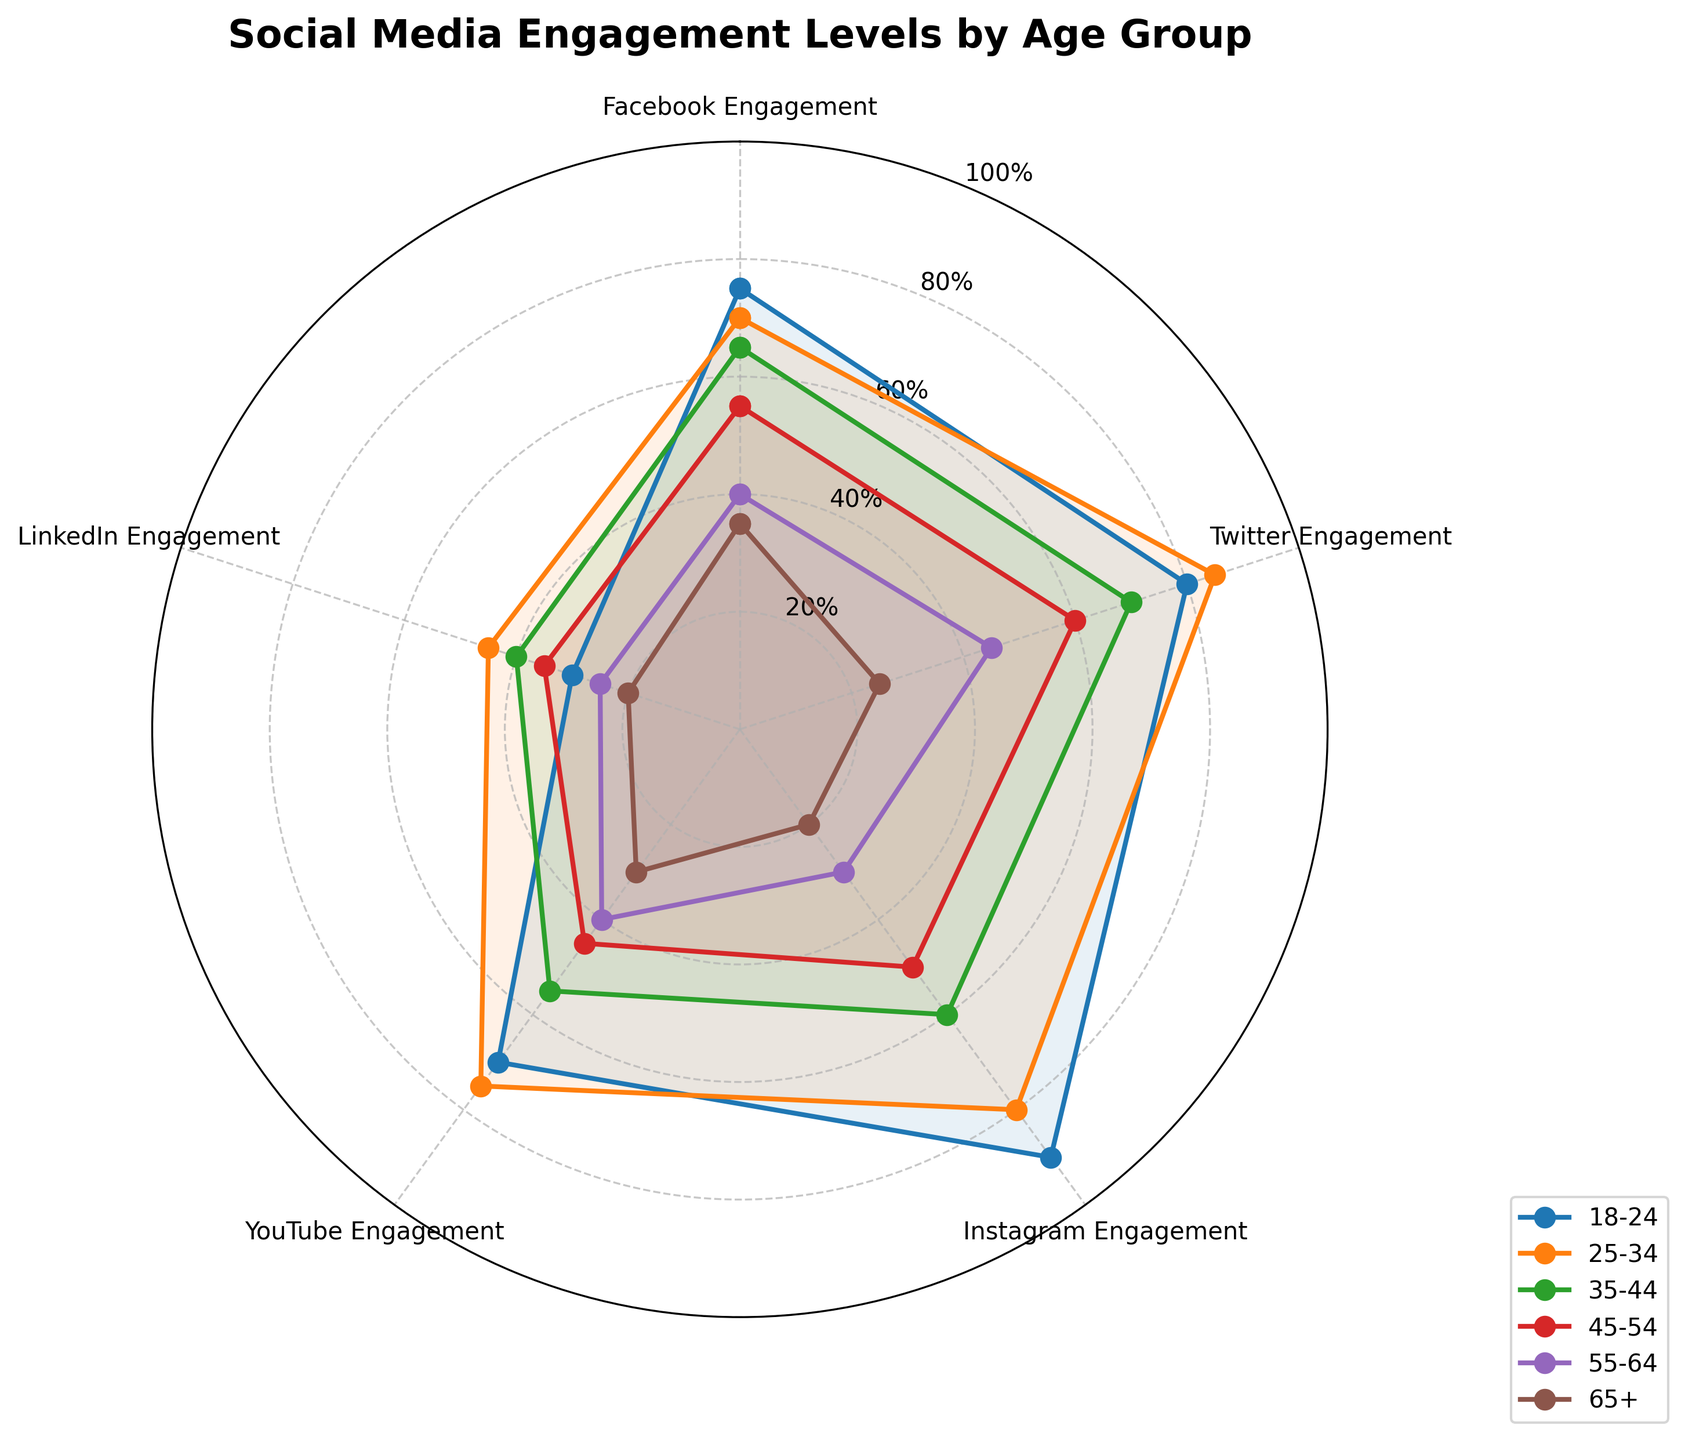What is the title of the chart? The title of the chart is written at the top of the figure, centered and in bold font. It reads "Social Media Engagement Levels by Age Group."
Answer: Social Media Engagement Levels by Age Group How many age groups are displayed in the chart? There are sections of the radial lines each representing different age groups. Count the number of unique labels that are plotted along the lines representing age groups.
Answer: Six Which age group has the highest engagement on Instagram? Look at the points corresponding to Instagram for each age group and identify the highest value. The age group with the peak value is the one with the highest engagement.
Answer: 18-24 Compare the Facebook engagement levels between age groups 18-24 and 65+. Which one is higher? Locate the points for Facebook engagement of age groups 18-24 and 65+. The line for the 18-24 age group reaches higher on the radial scale than the 65+ line.
Answer: 18-24 What is the average YouTube engagement level for the age groups 18-24 and 45-54 combined? Add the YouTube engagement values for 18-24 and 45-54 age groups (70 and 45), then divide by 2 to find the average: (70+45)/2.
Answer: 57.5 Which social media platform has the highest engagement for the age group 25-34? Identify the highest value among the points corresponding to the 25-34 age group across all social media platforms. The peak is on Twitter at 85.
Answer: Twitter What is the difference in LinkedIn engagement between the age groups 35-44 and 55-64? Subtract the LinkedIn engagement value for the 55-64 age group from that of the 35-44 age group: 40 - 25.
Answer: 15 Which age group has the lowest overall average engagement across all social media platforms, and what is that average? Sum the engagement levels of each age group across all platforms and divide by the number of platforms (5). Compare these averages: For 65+, (35+25+20+30+20)/5 = 26.
Answer: 65+; 26 By how many percentage points is YouTube engagement lower for age group 55-64 compared to age group 25-34? Subtract the YouTube engagement value of the 55-64 age group from the 25-34 age group: 75 - 40.
Answer: 35 Which social media platform shows the least variation in engagement levels across all age groups? Compare the range (difference between the highest and lowest values) of engagement levels across all age groups for each platform. LinkedIn has values from 20 to 45, a range of 25.
Answer: LinkedIn 